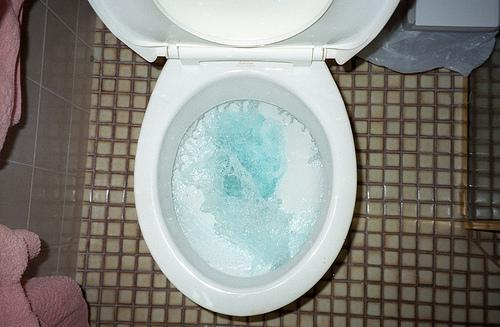Question: what kind of room is this?
Choices:
A. Bathroom.
B. Kitchen.
C. Den.
D. Bedroom.
Answer with the letter. Answer: A Question: what is the floor made of?
Choices:
A. Tiles.
B. Wood.
C. Linoleum.
D. Concrete.
Answer with the letter. Answer: A Question: what color is the tile?
Choices:
A. Beige.
B. Blue.
C. Pink.
D. White.
Answer with the letter. Answer: A Question: how many people are in the bathroom?
Choices:
A. None.
B. Two.
C. Three.
D. Ten.
Answer with the letter. Answer: A Question: where is this taking place?
Choices:
A. Near the sink.
B. In the shower.
C. In the bath.
D. Over a toilet.
Answer with the letter. Answer: D 